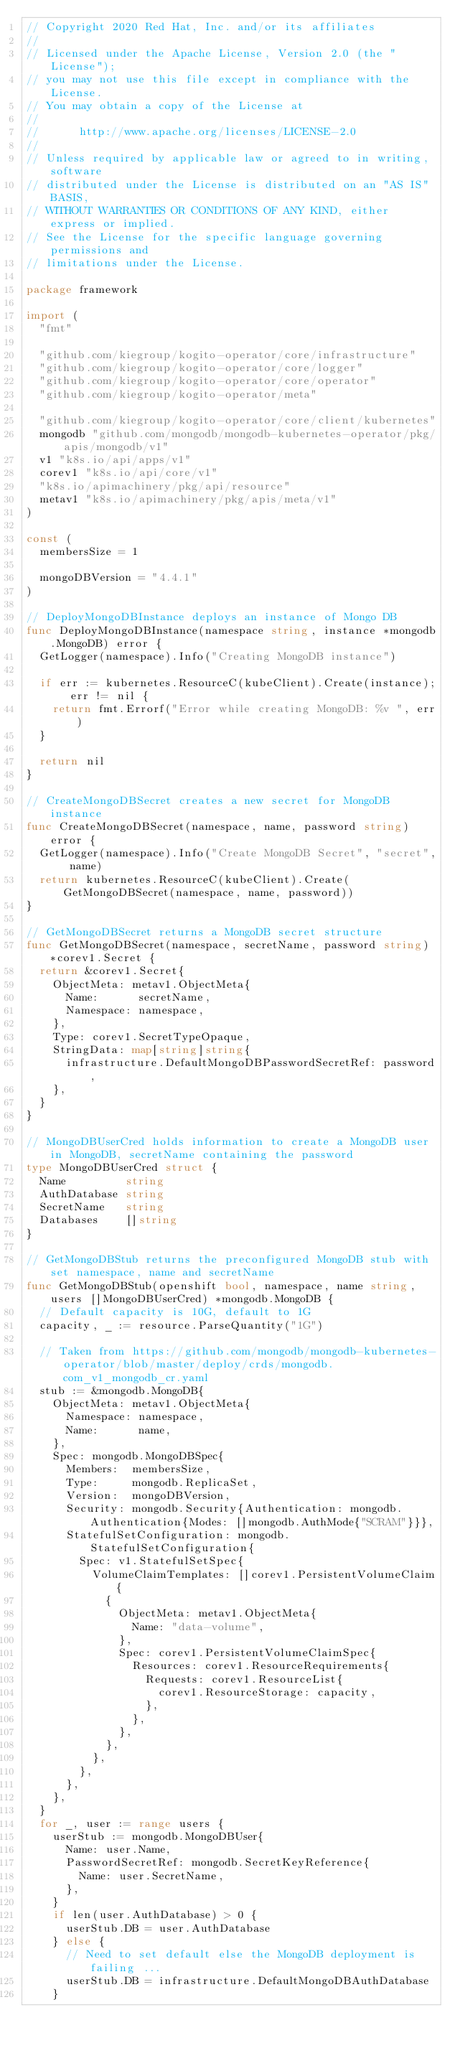<code> <loc_0><loc_0><loc_500><loc_500><_Go_>// Copyright 2020 Red Hat, Inc. and/or its affiliates
//
// Licensed under the Apache License, Version 2.0 (the "License");
// you may not use this file except in compliance with the License.
// You may obtain a copy of the License at
//
//      http://www.apache.org/licenses/LICENSE-2.0
//
// Unless required by applicable law or agreed to in writing, software
// distributed under the License is distributed on an "AS IS" BASIS,
// WITHOUT WARRANTIES OR CONDITIONS OF ANY KIND, either express or implied.
// See the License for the specific language governing permissions and
// limitations under the License.

package framework

import (
	"fmt"

	"github.com/kiegroup/kogito-operator/core/infrastructure"
	"github.com/kiegroup/kogito-operator/core/logger"
	"github.com/kiegroup/kogito-operator/core/operator"
	"github.com/kiegroup/kogito-operator/meta"

	"github.com/kiegroup/kogito-operator/core/client/kubernetes"
	mongodb "github.com/mongodb/mongodb-kubernetes-operator/pkg/apis/mongodb/v1"
	v1 "k8s.io/api/apps/v1"
	corev1 "k8s.io/api/core/v1"
	"k8s.io/apimachinery/pkg/api/resource"
	metav1 "k8s.io/apimachinery/pkg/apis/meta/v1"
)

const (
	membersSize = 1

	mongoDBVersion = "4.4.1"
)

// DeployMongoDBInstance deploys an instance of Mongo DB
func DeployMongoDBInstance(namespace string, instance *mongodb.MongoDB) error {
	GetLogger(namespace).Info("Creating MongoDB instance")

	if err := kubernetes.ResourceC(kubeClient).Create(instance); err != nil {
		return fmt.Errorf("Error while creating MongoDB: %v ", err)
	}

	return nil
}

// CreateMongoDBSecret creates a new secret for MongoDB instance
func CreateMongoDBSecret(namespace, name, password string) error {
	GetLogger(namespace).Info("Create MongoDB Secret", "secret", name)
	return kubernetes.ResourceC(kubeClient).Create(GetMongoDBSecret(namespace, name, password))
}

// GetMongoDBSecret returns a MongoDB secret structure
func GetMongoDBSecret(namespace, secretName, password string) *corev1.Secret {
	return &corev1.Secret{
		ObjectMeta: metav1.ObjectMeta{
			Name:      secretName,
			Namespace: namespace,
		},
		Type: corev1.SecretTypeOpaque,
		StringData: map[string]string{
			infrastructure.DefaultMongoDBPasswordSecretRef: password,
		},
	}
}

// MongoDBUserCred holds information to create a MongoDB user in MongoDB, secretName containing the password
type MongoDBUserCred struct {
	Name         string
	AuthDatabase string
	SecretName   string
	Databases    []string
}

// GetMongoDBStub returns the preconfigured MongoDB stub with set namespace, name and secretName
func GetMongoDBStub(openshift bool, namespace, name string, users []MongoDBUserCred) *mongodb.MongoDB {
	// Default capacity is 10G, default to 1G
	capacity, _ := resource.ParseQuantity("1G")

	// Taken from https://github.com/mongodb/mongodb-kubernetes-operator/blob/master/deploy/crds/mongodb.com_v1_mongodb_cr.yaml
	stub := &mongodb.MongoDB{
		ObjectMeta: metav1.ObjectMeta{
			Namespace: namespace,
			Name:      name,
		},
		Spec: mongodb.MongoDBSpec{
			Members:  membersSize,
			Type:     mongodb.ReplicaSet,
			Version:  mongoDBVersion,
			Security: mongodb.Security{Authentication: mongodb.Authentication{Modes: []mongodb.AuthMode{"SCRAM"}}},
			StatefulSetConfiguration: mongodb.StatefulSetConfiguration{
				Spec: v1.StatefulSetSpec{
					VolumeClaimTemplates: []corev1.PersistentVolumeClaim{
						{
							ObjectMeta: metav1.ObjectMeta{
								Name: "data-volume",
							},
							Spec: corev1.PersistentVolumeClaimSpec{
								Resources: corev1.ResourceRequirements{
									Requests: corev1.ResourceList{
										corev1.ResourceStorage: capacity,
									},
								},
							},
						},
					},
				},
			},
		},
	}
	for _, user := range users {
		userStub := mongodb.MongoDBUser{
			Name: user.Name,
			PasswordSecretRef: mongodb.SecretKeyReference{
				Name: user.SecretName,
			},
		}
		if len(user.AuthDatabase) > 0 {
			userStub.DB = user.AuthDatabase
		} else {
			// Need to set default else the MongoDB deployment is failing ...
			userStub.DB = infrastructure.DefaultMongoDBAuthDatabase
		}</code> 